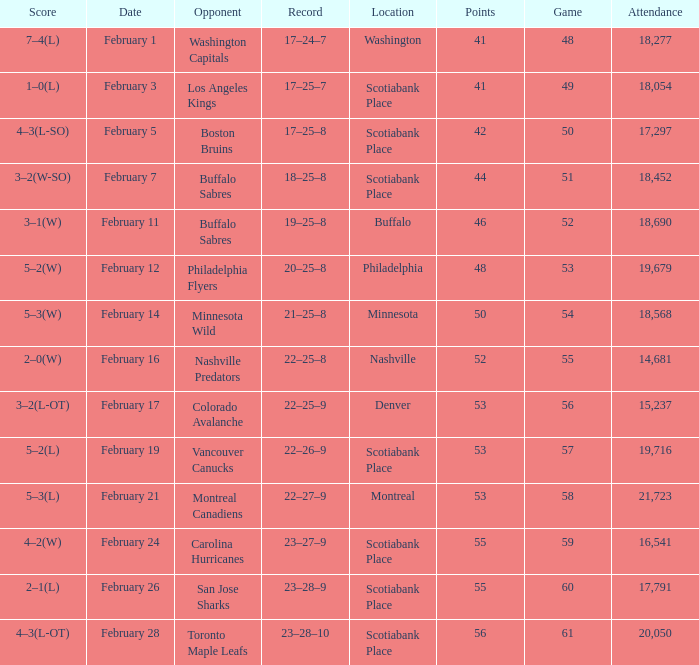What sum of game has an attendance of 18,690? 52.0. 